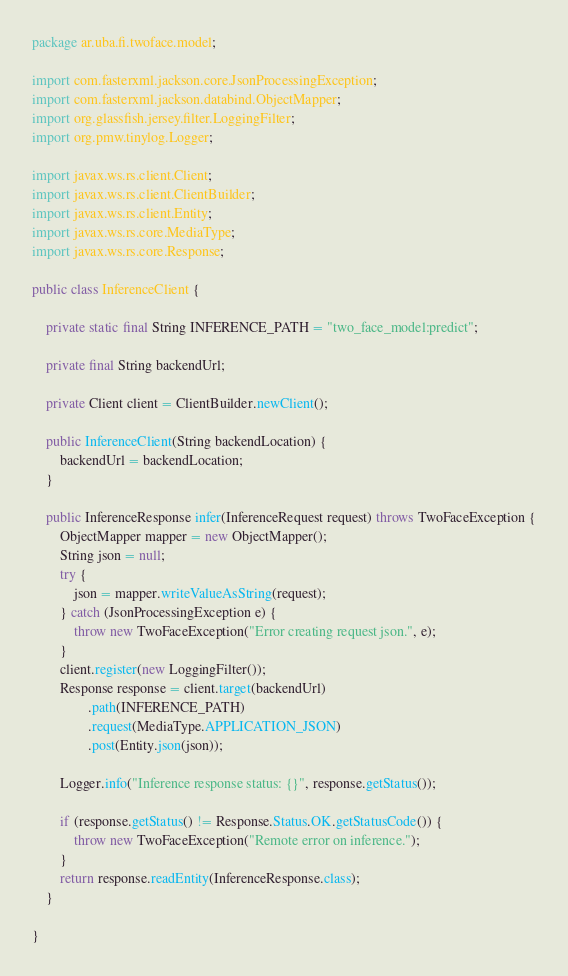<code> <loc_0><loc_0><loc_500><loc_500><_Java_>package ar.uba.fi.twoface.model;

import com.fasterxml.jackson.core.JsonProcessingException;
import com.fasterxml.jackson.databind.ObjectMapper;
import org.glassfish.jersey.filter.LoggingFilter;
import org.pmw.tinylog.Logger;

import javax.ws.rs.client.Client;
import javax.ws.rs.client.ClientBuilder;
import javax.ws.rs.client.Entity;
import javax.ws.rs.core.MediaType;
import javax.ws.rs.core.Response;

public class InferenceClient {

    private static final String INFERENCE_PATH = "two_face_model:predict";

    private final String backendUrl;

    private Client client = ClientBuilder.newClient();

    public InferenceClient(String backendLocation) {
        backendUrl = backendLocation;
    }

    public InferenceResponse infer(InferenceRequest request) throws TwoFaceException {
        ObjectMapper mapper = new ObjectMapper();
        String json = null;
        try {
            json = mapper.writeValueAsString(request);
        } catch (JsonProcessingException e) {
            throw new TwoFaceException("Error creating request json.", e);
        }
        client.register(new LoggingFilter());
        Response response = client.target(backendUrl)
                .path(INFERENCE_PATH)
                .request(MediaType.APPLICATION_JSON)
                .post(Entity.json(json));

        Logger.info("Inference response status: {}", response.getStatus());

        if (response.getStatus() != Response.Status.OK.getStatusCode()) {
            throw new TwoFaceException("Remote error on inference.");
        }
        return response.readEntity(InferenceResponse.class);
    }

}
</code> 